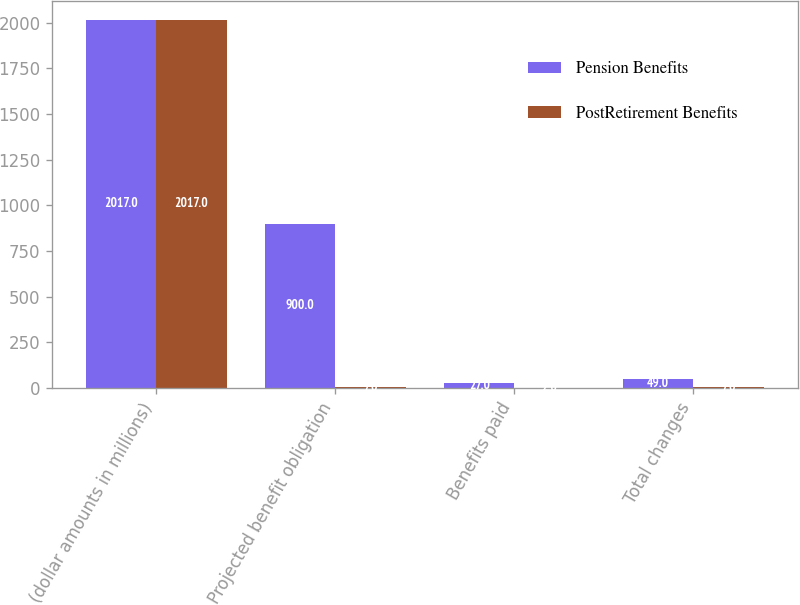Convert chart. <chart><loc_0><loc_0><loc_500><loc_500><stacked_bar_chart><ecel><fcel>(dollar amounts in millions)<fcel>Projected benefit obligation<fcel>Benefits paid<fcel>Total changes<nl><fcel>Pension Benefits<fcel>2017<fcel>900<fcel>27<fcel>49<nl><fcel>PostRetirement Benefits<fcel>2017<fcel>7<fcel>2<fcel>7<nl></chart> 